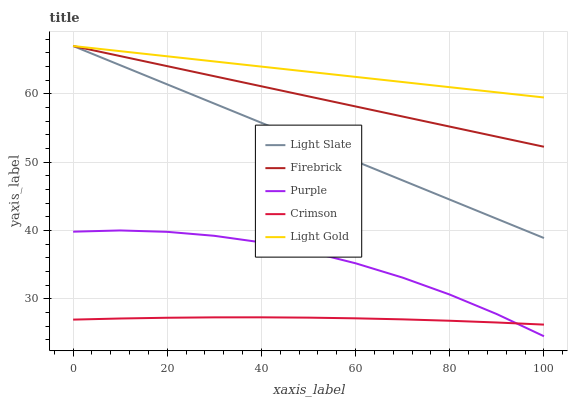Does Crimson have the minimum area under the curve?
Answer yes or no. Yes. Does Light Gold have the maximum area under the curve?
Answer yes or no. Yes. Does Purple have the minimum area under the curve?
Answer yes or no. No. Does Purple have the maximum area under the curve?
Answer yes or no. No. Is Light Slate the smoothest?
Answer yes or no. Yes. Is Purple the roughest?
Answer yes or no. Yes. Is Firebrick the smoothest?
Answer yes or no. No. Is Firebrick the roughest?
Answer yes or no. No. Does Purple have the lowest value?
Answer yes or no. Yes. Does Firebrick have the lowest value?
Answer yes or no. No. Does Light Gold have the highest value?
Answer yes or no. Yes. Does Purple have the highest value?
Answer yes or no. No. Is Purple less than Light Gold?
Answer yes or no. Yes. Is Firebrick greater than Purple?
Answer yes or no. Yes. Does Light Gold intersect Firebrick?
Answer yes or no. Yes. Is Light Gold less than Firebrick?
Answer yes or no. No. Is Light Gold greater than Firebrick?
Answer yes or no. No. Does Purple intersect Light Gold?
Answer yes or no. No. 